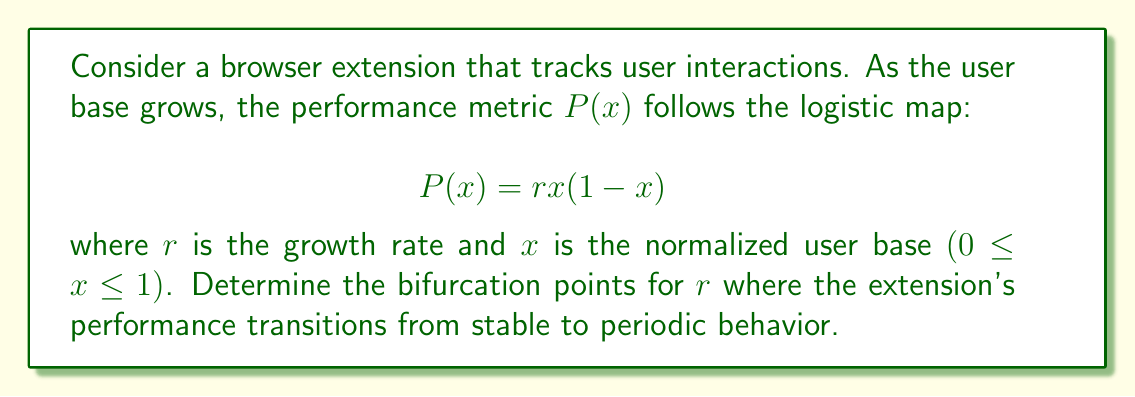Show me your answer to this math problem. To find the bifurcation points, we need to analyze the stability of the fixed points of the logistic map.

1. Find the fixed points:
   Set $P(x) = x$
   $$rx(1-x) = x$$
   $$rx - rx^2 = x$$
   $$rx^2 - (r+1)x + 0 = 0$$
   
   Solving this quadratic equation:
   $$x = 0$$ or $$x = \frac{r-1}{r}$$

2. Analyze stability:
   The derivative of $P(x)$ is:
   $$P'(x) = r(1-2x)$$

3. For the fixed point $x = 0$:
   $$|P'(0)| = |r| < 1$$ for stability
   This gives us $-1 < r < 1$

4. For the fixed point $x = \frac{r-1}{r}$:
   $$|P'(\frac{r-1}{r})| = |r(1-2(\frac{r-1}{r}))| = |2-r| < 1$$ for stability
   This gives us $1 < r < 3$

5. The first bifurcation occurs when $r = 3$, where the system transitions from a stable fixed point to a 2-cycle.

6. Subsequent bifurcations (period-doubling) occur at:
   - $r ≈ 3.44949$ (transition to 4-cycle)
   - $r ≈ 3.54409$ (transition to 8-cycle)
   - $r ≈ 3.56995$ (transition to 16-cycle)
   
   These values converge to the onset of chaos at $r ≈ 3.56995$.
Answer: $r = 1, 3, 3.44949, 3.54409, 3.56995$ 